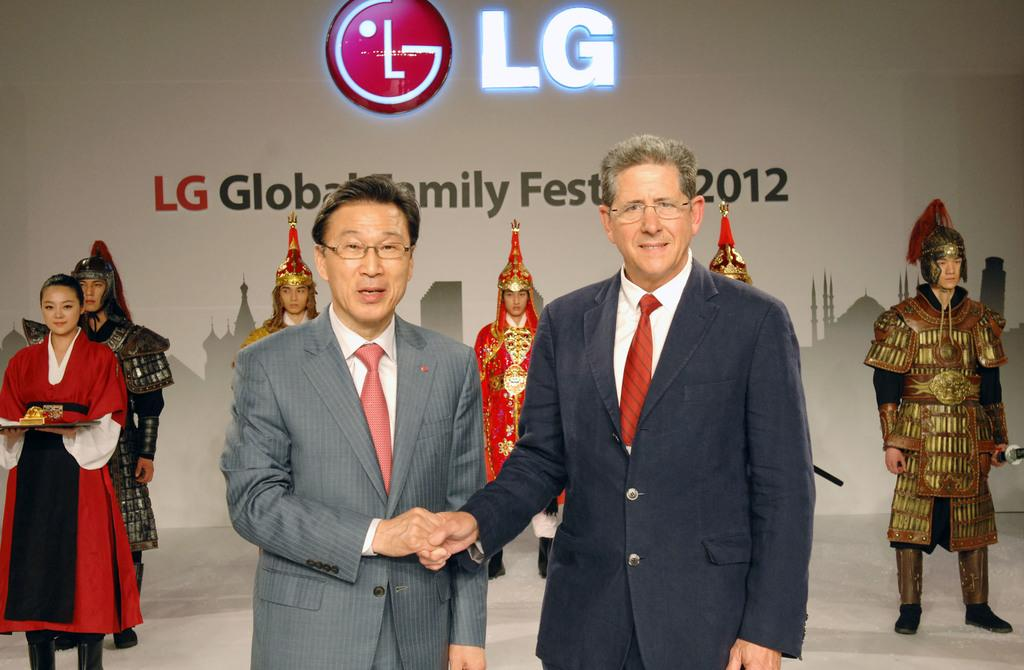How many people are in the group that is visible in the image? There is a group of people in the image, but the exact number is not specified. What can be observed about some of the people in the group? Some people in the group are wearing spectacles and some are wearing costumes. What can be seen in the background of the image? There is a hoarding visible in the background of the image. What type of watch is the person wearing in the image? There is no person wearing a watch in the image. What trick is the group performing in the image? There is no trick being performed by the group in the image. 